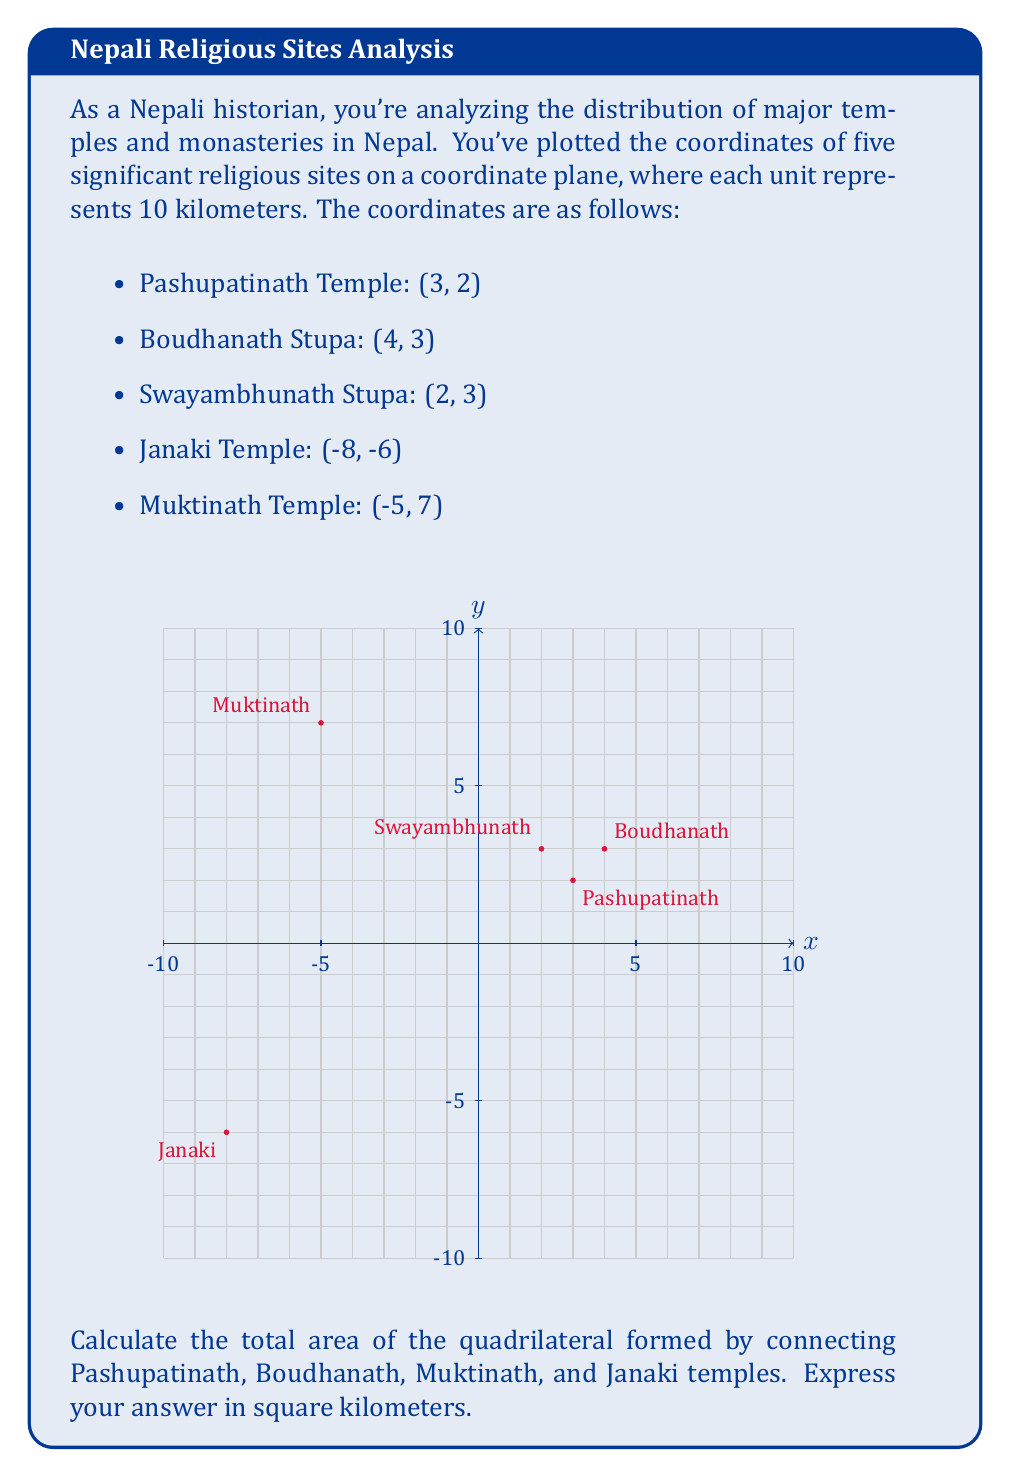Can you answer this question? To solve this problem, we'll follow these steps:

1) First, we need to identify the coordinates of the four temples forming the quadrilateral:
   Pashupatinath: (3, 2)
   Boudhanath: (4, 3)
   Muktinath: (-5, 7)
   Janaki: (-8, -6)

2) We can calculate the area of this quadrilateral using the Shoelace formula (also known as the surveyor's formula). The formula for a quadrilateral with vertices $(x_1, y_1)$, $(x_2, y_2)$, $(x_3, y_3)$, and $(x_4, y_4)$ is:

   $$A = \frac{1}{2}|(x_1y_2 + x_2y_3 + x_3y_4 + x_4y_1) - (y_1x_2 + y_2x_3 + y_3x_4 + y_4x_1)|$$

3) Let's substitute our coordinates into this formula:

   $$A = \frac{1}{2}|(3 \cdot 3 + 4 \cdot 7 + (-5) \cdot (-6) + (-8) \cdot 2) - (2 \cdot 4 + 3 \cdot (-5) + 7 \cdot (-8) + (-6) \cdot 3)|$$

4) Let's calculate each part:
   $$(3 \cdot 3 + 4 \cdot 7 + (-5) \cdot (-6) + (-8) \cdot 2) = 9 + 28 + 30 - 16 = 51$$
   $$(2 \cdot 4 + 3 \cdot (-5) + 7 \cdot (-8) + (-6) \cdot 3) = 8 - 15 - 56 - 18 = -81$$

5) Substituting back:

   $$A = \frac{1}{2}|51 - (-81)| = \frac{1}{2}|51 + 81| = \frac{1}{2}(132) = 66$$

6) Remember that each unit represents 10 kilometers. So we need to multiply our result by $10^2 = 100$ to get the area in square kilometers:

   $$66 \cdot 100 = 6600$$

Therefore, the area of the quadrilateral is 6600 square kilometers.
Answer: 6600 km² 